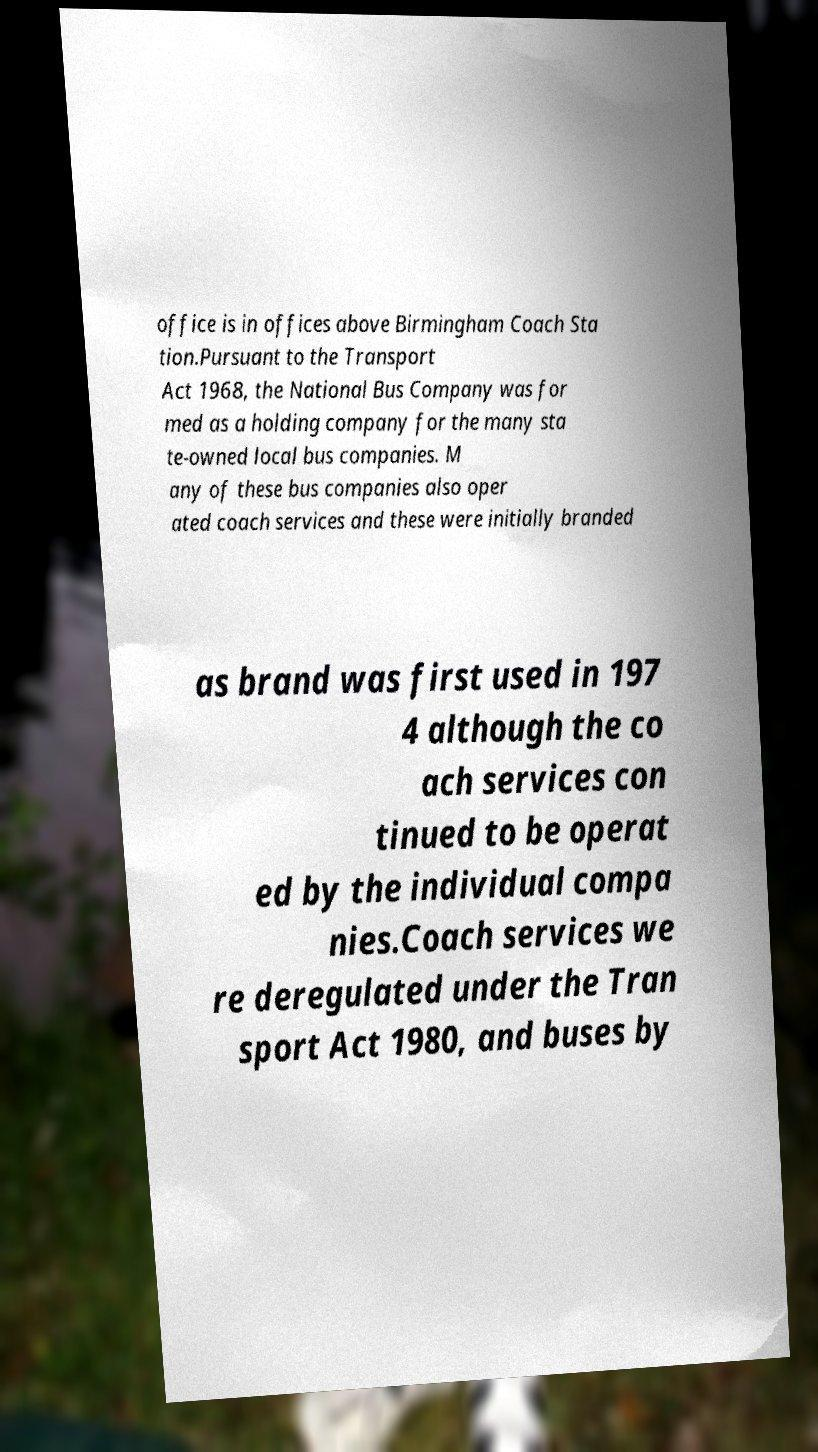Could you extract and type out the text from this image? office is in offices above Birmingham Coach Sta tion.Pursuant to the Transport Act 1968, the National Bus Company was for med as a holding company for the many sta te-owned local bus companies. M any of these bus companies also oper ated coach services and these were initially branded as brand was first used in 197 4 although the co ach services con tinued to be operat ed by the individual compa nies.Coach services we re deregulated under the Tran sport Act 1980, and buses by 